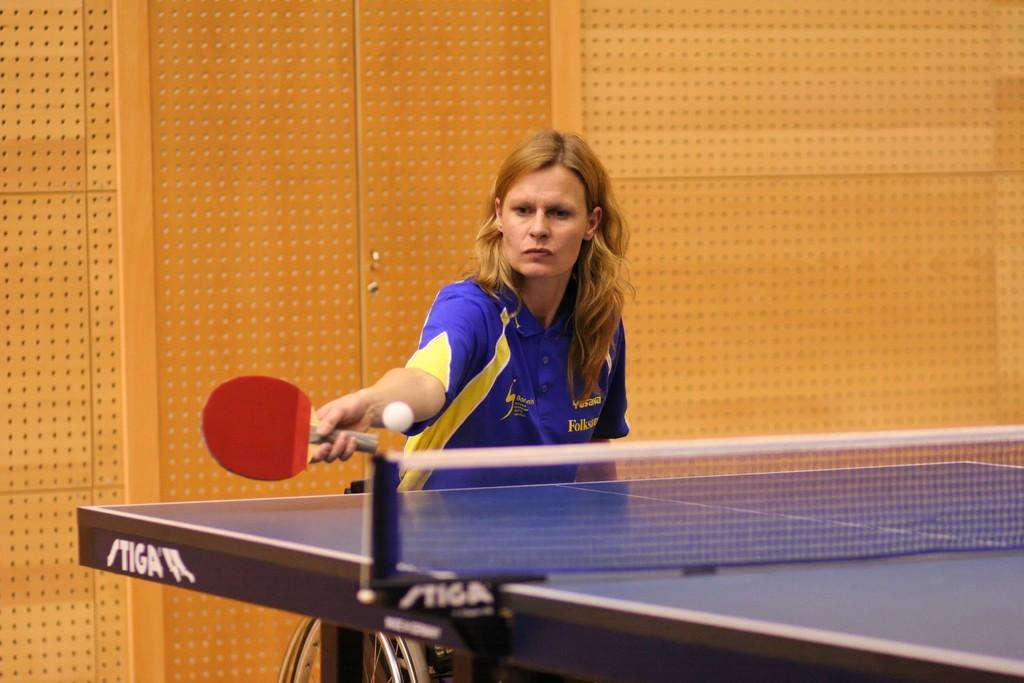Who is present in the image? There is a woman in the image. What is the woman holding in the image? The woman is holding a bat. What is in front of the woman? There is a table in front of the woman. What else can be seen in the image? There is a ball in the image. What is visible in the background of the image? There is a wall in the background of the image. What type of meat is the woman preparing on the table in the image? There is no meat present in the image. 